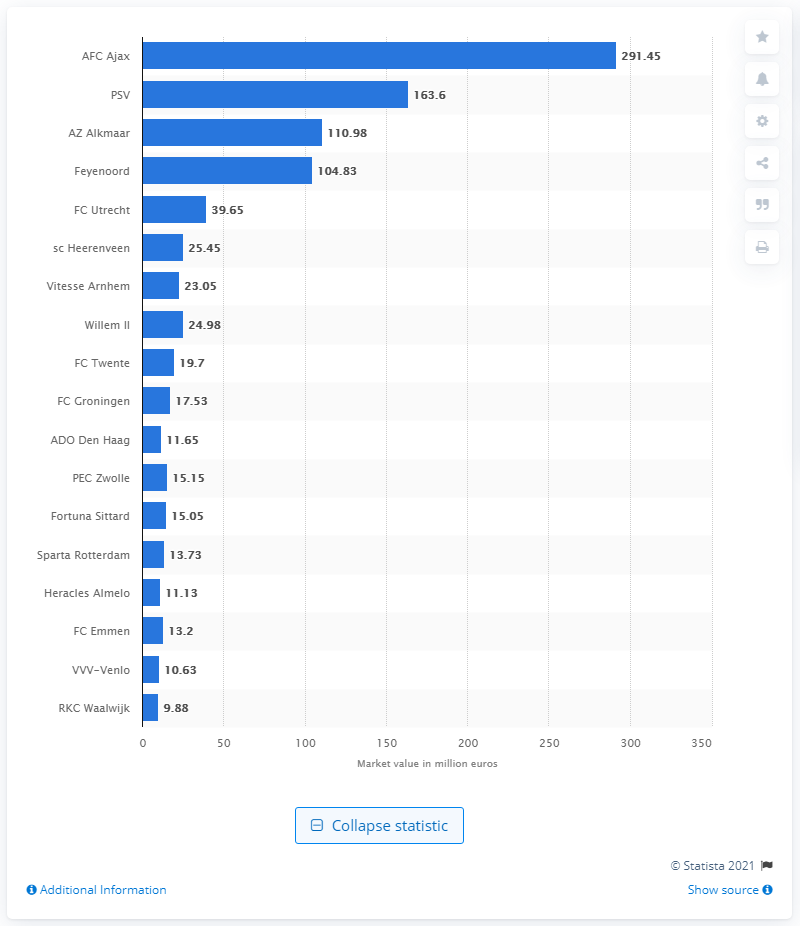List a handful of essential elements in this visual. The market value of RKC Waalwijk was 9.88. As of December 2020, the market value of PSV Eindhoven was 163.6 million. As of December 2020, the market value of Ajax Amsterdam was 291.45. 